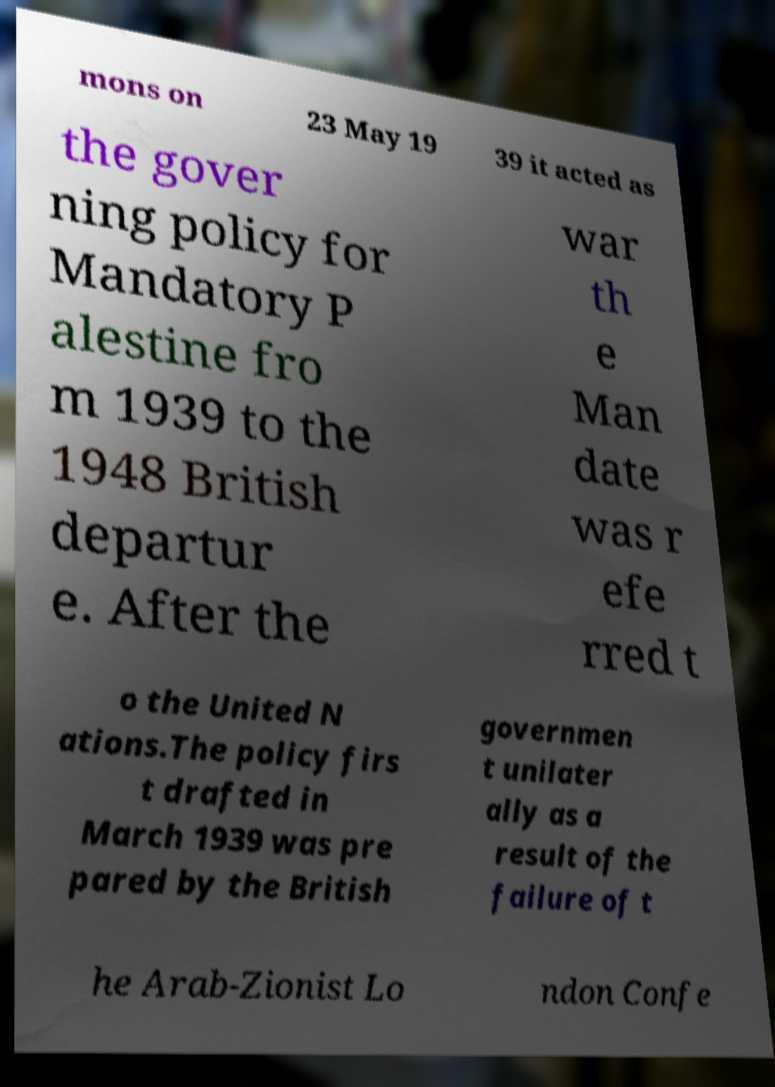Could you extract and type out the text from this image? mons on 23 May 19 39 it acted as the gover ning policy for Mandatory P alestine fro m 1939 to the 1948 British departur e. After the war th e Man date was r efe rred t o the United N ations.The policy firs t drafted in March 1939 was pre pared by the British governmen t unilater ally as a result of the failure of t he Arab-Zionist Lo ndon Confe 